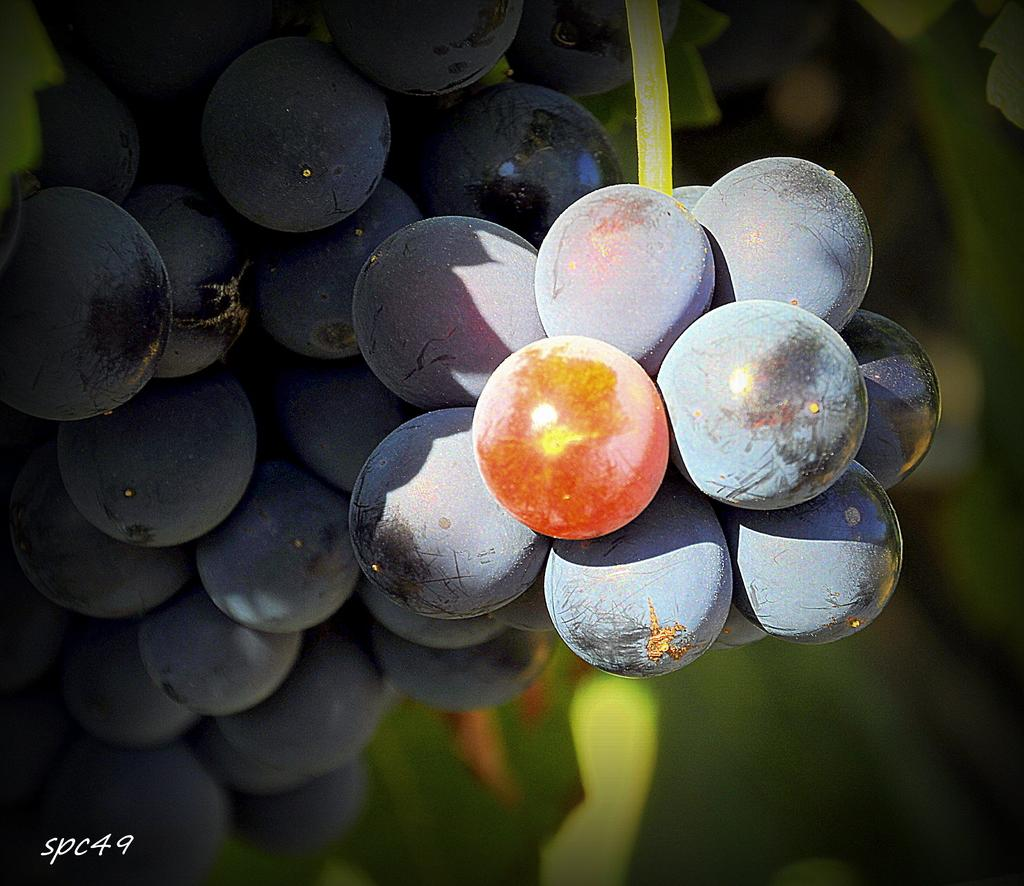What type of fruit is present in the image? There are black grapes in the image. How would you describe the background of the image? The background of the image is blurred. What can be found at the bottom of the image? There are letters and numbers at the bottom of the image. What is the income of the person talking in the image? There is no person talking in the image, and therefore no income can be determined. 